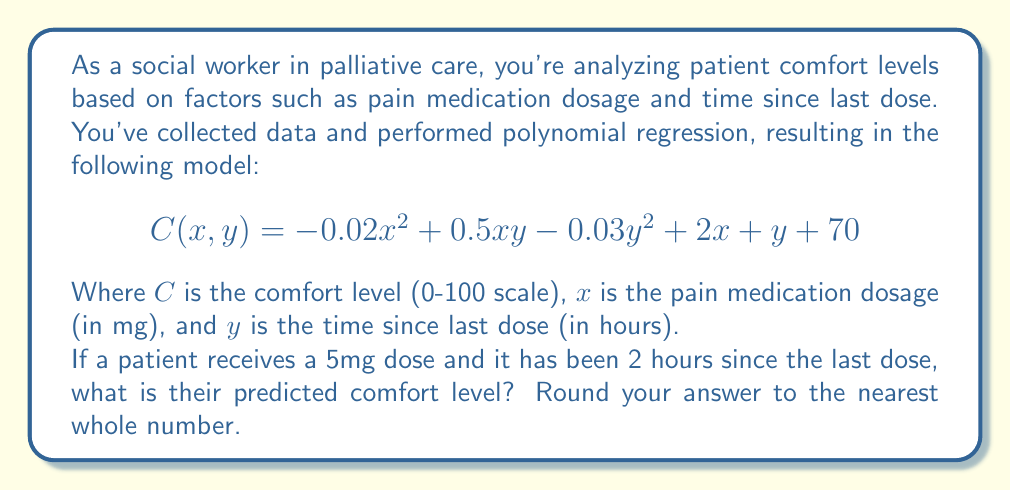Show me your answer to this math problem. To solve this problem, we'll follow these steps:

1) We have the polynomial function:
   $C(x, y) = -0.02x^2 + 0.5xy - 0.03y^2 + 2x + y + 70$

2) We need to substitute the given values:
   $x = 5$ (dosage in mg)
   $y = 2$ (time since last dose in hours)

3) Let's substitute these values into the equation:
   $C(5, 2) = -0.02(5^2) + 0.5(5)(2) - 0.03(2^2) + 2(5) + 2 + 70$

4) Now, let's calculate each term:
   $-0.02(5^2) = -0.02(25) = -0.5$
   $0.5(5)(2) = 5$
   $-0.03(2^2) = -0.03(4) = -0.12$
   $2(5) = 10$
   $2$ (remains as is)
   $70$ (remains as is)

5) Sum up all the terms:
   $C(5, 2) = -0.5 + 5 - 0.12 + 10 + 2 + 70 = 86.38$

6) Rounding to the nearest whole number:
   $86.38 \approx 86$

Therefore, the predicted comfort level for the patient is 86.
Answer: 86 